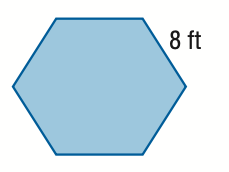Question: Find the area of the regular polygon figure. Round to the nearest tenth.
Choices:
A. 27.7
B. 55.4
C. 166.3
D. 332.6
Answer with the letter. Answer: C 